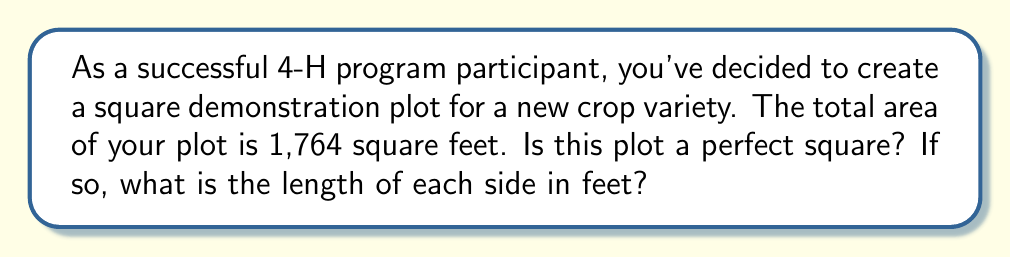Show me your answer to this math problem. To determine if the farm plot is a perfect square, we need to find the square root of its area and check if it's a whole number.

Step 1: Calculate the square root of the area.
$$\sqrt{1,764} = \sqrt{4 \times 441} = 2\sqrt{441} = 2 \times 21 = 42$$

Step 2: Verify if the result is a whole number.
The square root (42) is indeed a whole number.

Step 3: Check if 42 squared equals the original area.
$$42^2 = 42 \times 42 = 1,764$$

Since 42 squared equals the original area, we can confirm that 1,764 square feet is a perfect square.

Step 4: Determine the length of each side.
The length of each side is equal to the square root we calculated: 42 feet.
Answer: Yes; 42 feet 